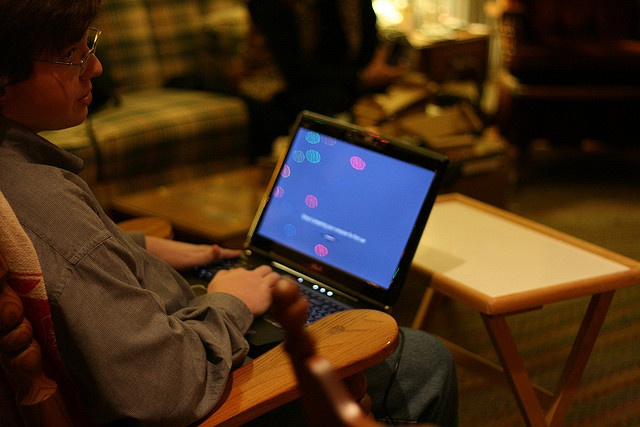Describe the objects in this image and their specific colors. I can see people in black, maroon, and brown tones, chair in black, red, and maroon tones, laptop in black and blue tones, and couch in black, maroon, and olive tones in this image. 